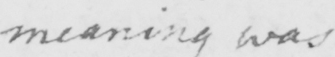Please transcribe the handwritten text in this image. meaning was 